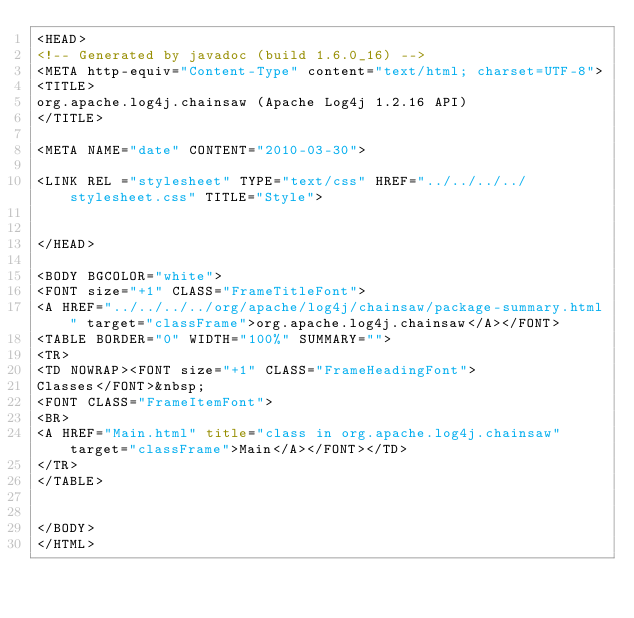Convert code to text. <code><loc_0><loc_0><loc_500><loc_500><_HTML_><HEAD>
<!-- Generated by javadoc (build 1.6.0_16) -->
<META http-equiv="Content-Type" content="text/html; charset=UTF-8">
<TITLE>
org.apache.log4j.chainsaw (Apache Log4j 1.2.16 API)
</TITLE>

<META NAME="date" CONTENT="2010-03-30">

<LINK REL ="stylesheet" TYPE="text/css" HREF="../../../../stylesheet.css" TITLE="Style">


</HEAD>

<BODY BGCOLOR="white">
<FONT size="+1" CLASS="FrameTitleFont">
<A HREF="../../../../org/apache/log4j/chainsaw/package-summary.html" target="classFrame">org.apache.log4j.chainsaw</A></FONT>
<TABLE BORDER="0" WIDTH="100%" SUMMARY="">
<TR>
<TD NOWRAP><FONT size="+1" CLASS="FrameHeadingFont">
Classes</FONT>&nbsp;
<FONT CLASS="FrameItemFont">
<BR>
<A HREF="Main.html" title="class in org.apache.log4j.chainsaw" target="classFrame">Main</A></FONT></TD>
</TR>
</TABLE>


</BODY>
</HTML>
</code> 